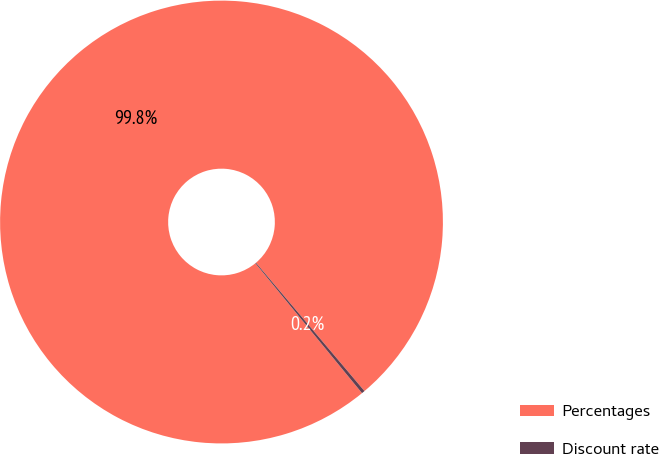Convert chart to OTSL. <chart><loc_0><loc_0><loc_500><loc_500><pie_chart><fcel>Percentages<fcel>Discount rate<nl><fcel>99.77%<fcel>0.23%<nl></chart> 